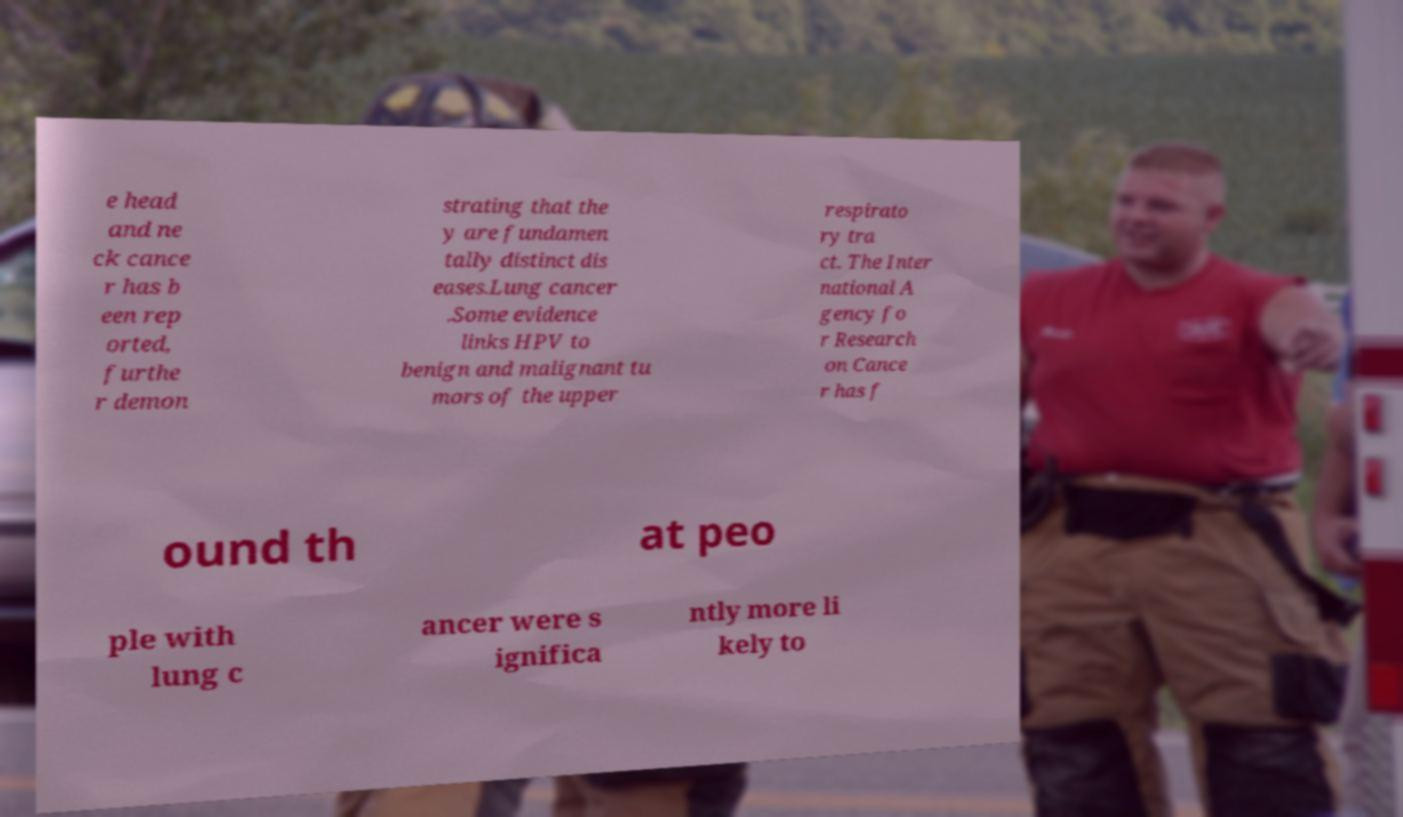There's text embedded in this image that I need extracted. Can you transcribe it verbatim? e head and ne ck cance r has b een rep orted, furthe r demon strating that the y are fundamen tally distinct dis eases.Lung cancer .Some evidence links HPV to benign and malignant tu mors of the upper respirato ry tra ct. The Inter national A gency fo r Research on Cance r has f ound th at peo ple with lung c ancer were s ignifica ntly more li kely to 